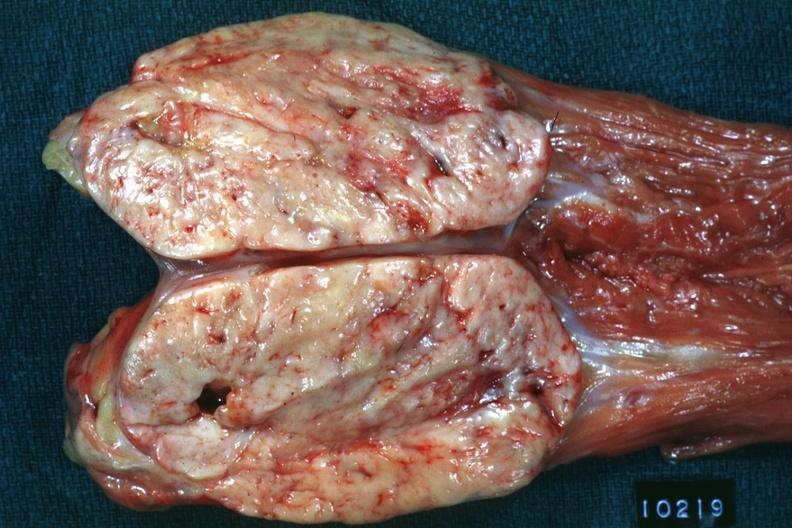what is present?
Answer the question using a single word or phrase. Retroperitoneal leiomyosarcoma 